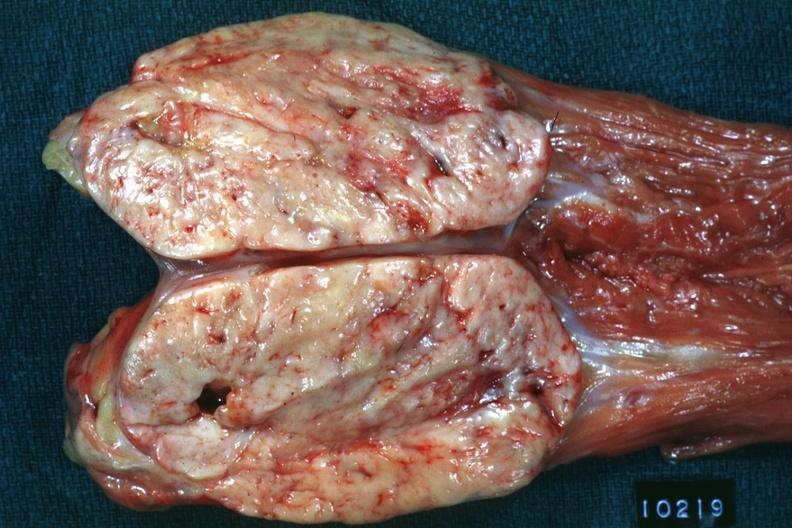what is present?
Answer the question using a single word or phrase. Retroperitoneal leiomyosarcoma 